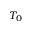<formula> <loc_0><loc_0><loc_500><loc_500>T _ { 0 }</formula> 